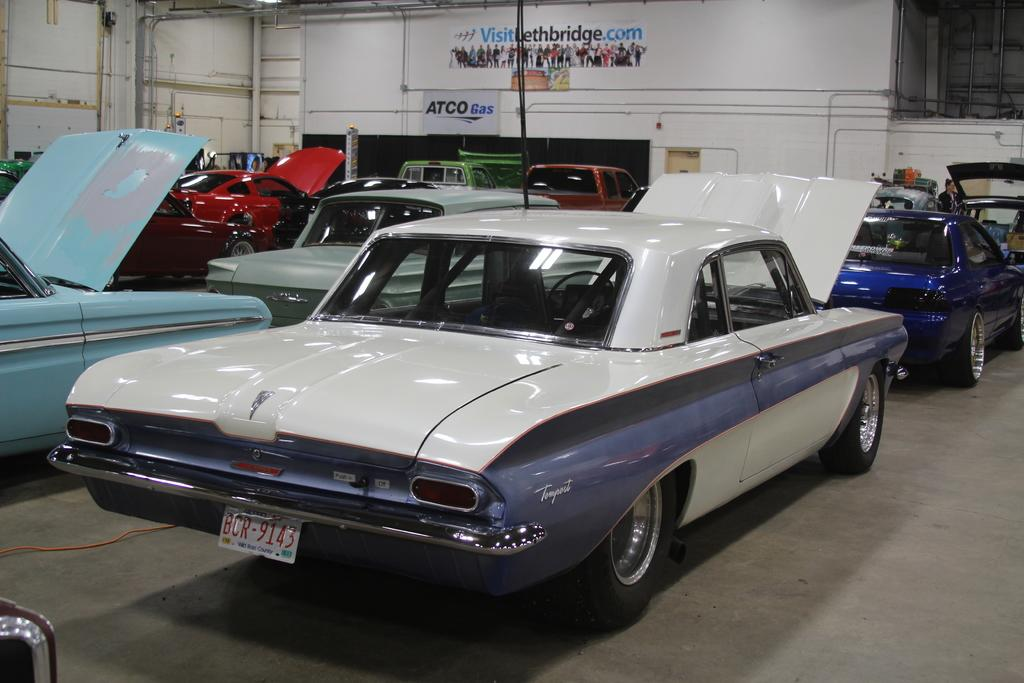What type of vehicles can be seen on the ground in the image? There are cars on the ground in the image. What can be seen in the background of the image? There are pipes and a wall visible in the background of the image. What type of signage is present in the background of the image? Banners are present in the background of the image. What type of precipitation can be seen falling from the sky in the image? There is no precipitation visible in the image, and therefore no type of precipitation can be identified. 